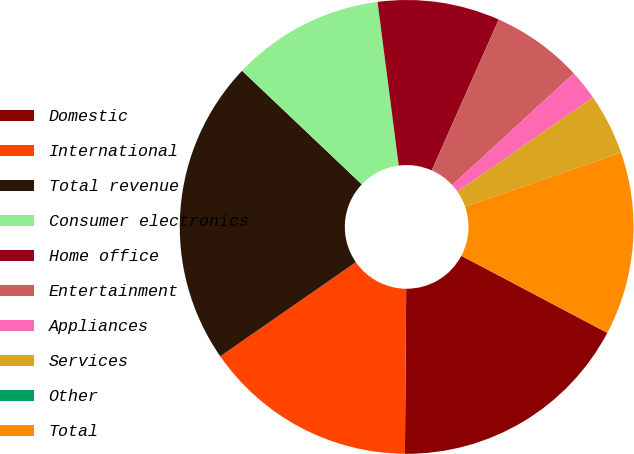<chart> <loc_0><loc_0><loc_500><loc_500><pie_chart><fcel>Domestic<fcel>International<fcel>Total revenue<fcel>Consumer electronics<fcel>Home office<fcel>Entertainment<fcel>Appliances<fcel>Services<fcel>Other<fcel>Total<nl><fcel>17.39%<fcel>15.22%<fcel>21.74%<fcel>10.87%<fcel>8.7%<fcel>6.52%<fcel>2.17%<fcel>4.35%<fcel>0.0%<fcel>13.04%<nl></chart> 